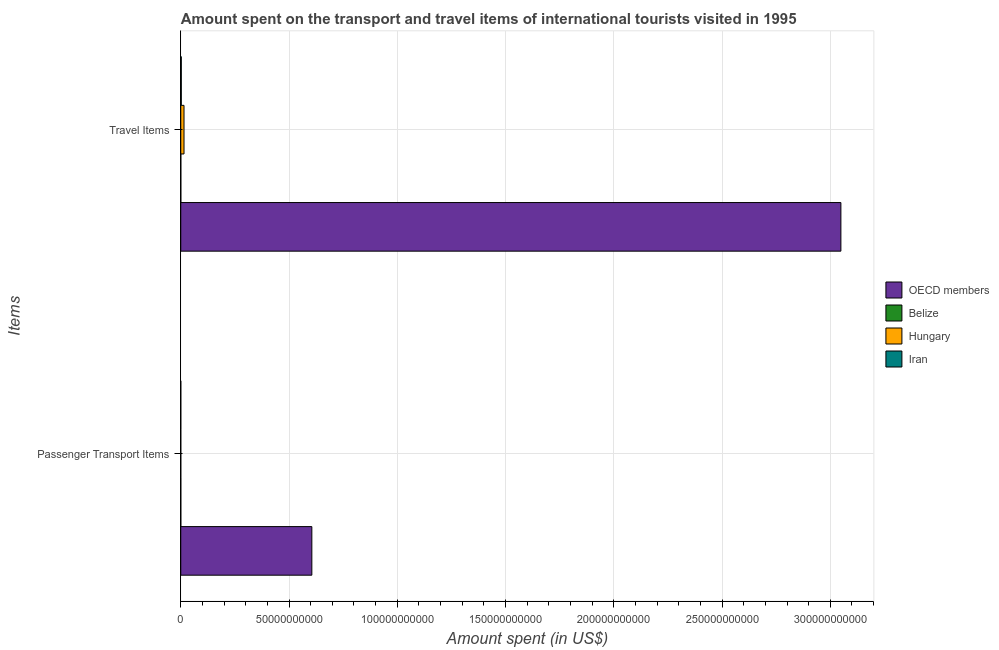How many different coloured bars are there?
Ensure brevity in your answer.  4. How many groups of bars are there?
Your answer should be very brief. 2. What is the label of the 2nd group of bars from the top?
Your response must be concise. Passenger Transport Items. Across all countries, what is the maximum amount spent in travel items?
Keep it short and to the point. 3.05e+11. Across all countries, what is the minimum amount spent on passenger transport items?
Provide a short and direct response. 3.00e+06. In which country was the amount spent in travel items minimum?
Give a very brief answer. Belize. What is the total amount spent in travel items in the graph?
Your answer should be compact. 3.07e+11. What is the difference between the amount spent in travel items in Belize and the amount spent on passenger transport items in OECD members?
Your response must be concise. -6.05e+1. What is the average amount spent in travel items per country?
Your response must be concise. 7.67e+1. What is the difference between the amount spent on passenger transport items and amount spent in travel items in Hungary?
Provide a succinct answer. -1.50e+09. What is the ratio of the amount spent in travel items in Hungary to that in OECD members?
Your answer should be very brief. 0. Is the amount spent on passenger transport items in Iran less than that in OECD members?
Your answer should be compact. Yes. What does the 1st bar from the top in Travel Items represents?
Offer a terse response. Iran. What does the 2nd bar from the bottom in Passenger Transport Items represents?
Make the answer very short. Belize. How many bars are there?
Keep it short and to the point. 8. How many countries are there in the graph?
Your answer should be very brief. 4. What is the difference between two consecutive major ticks on the X-axis?
Your answer should be compact. 5.00e+1. Are the values on the major ticks of X-axis written in scientific E-notation?
Your answer should be very brief. No. Does the graph contain any zero values?
Offer a very short reply. No. Does the graph contain grids?
Your answer should be compact. Yes. Where does the legend appear in the graph?
Give a very brief answer. Center right. What is the title of the graph?
Ensure brevity in your answer.  Amount spent on the transport and travel items of international tourists visited in 1995. Does "Zambia" appear as one of the legend labels in the graph?
Your response must be concise. No. What is the label or title of the X-axis?
Your answer should be very brief. Amount spent (in US$). What is the label or title of the Y-axis?
Ensure brevity in your answer.  Items. What is the Amount spent (in US$) in OECD members in Passenger Transport Items?
Provide a short and direct response. 6.05e+1. What is the Amount spent (in US$) of Belize in Passenger Transport Items?
Offer a very short reply. 1.20e+07. What is the Amount spent (in US$) in Hungary in Passenger Transport Items?
Your response must be concise. 3.00e+06. What is the Amount spent (in US$) in Iran in Passenger Transport Items?
Ensure brevity in your answer.  6.00e+06. What is the Amount spent (in US$) in OECD members in Travel Items?
Keep it short and to the point. 3.05e+11. What is the Amount spent (in US$) of Belize in Travel Items?
Your answer should be compact. 2.10e+07. What is the Amount spent (in US$) in Hungary in Travel Items?
Keep it short and to the point. 1.50e+09. What is the Amount spent (in US$) in Iran in Travel Items?
Provide a short and direct response. 2.41e+08. Across all Items, what is the maximum Amount spent (in US$) in OECD members?
Make the answer very short. 3.05e+11. Across all Items, what is the maximum Amount spent (in US$) of Belize?
Give a very brief answer. 2.10e+07. Across all Items, what is the maximum Amount spent (in US$) in Hungary?
Keep it short and to the point. 1.50e+09. Across all Items, what is the maximum Amount spent (in US$) of Iran?
Keep it short and to the point. 2.41e+08. Across all Items, what is the minimum Amount spent (in US$) in OECD members?
Your response must be concise. 6.05e+1. Across all Items, what is the minimum Amount spent (in US$) of Belize?
Give a very brief answer. 1.20e+07. Across all Items, what is the minimum Amount spent (in US$) in Hungary?
Offer a very short reply. 3.00e+06. Across all Items, what is the minimum Amount spent (in US$) of Iran?
Offer a terse response. 6.00e+06. What is the total Amount spent (in US$) of OECD members in the graph?
Your response must be concise. 3.65e+11. What is the total Amount spent (in US$) in Belize in the graph?
Provide a succinct answer. 3.30e+07. What is the total Amount spent (in US$) in Hungary in the graph?
Make the answer very short. 1.50e+09. What is the total Amount spent (in US$) of Iran in the graph?
Keep it short and to the point. 2.47e+08. What is the difference between the Amount spent (in US$) in OECD members in Passenger Transport Items and that in Travel Items?
Make the answer very short. -2.44e+11. What is the difference between the Amount spent (in US$) in Belize in Passenger Transport Items and that in Travel Items?
Ensure brevity in your answer.  -9.00e+06. What is the difference between the Amount spent (in US$) of Hungary in Passenger Transport Items and that in Travel Items?
Keep it short and to the point. -1.50e+09. What is the difference between the Amount spent (in US$) in Iran in Passenger Transport Items and that in Travel Items?
Provide a succinct answer. -2.35e+08. What is the difference between the Amount spent (in US$) in OECD members in Passenger Transport Items and the Amount spent (in US$) in Belize in Travel Items?
Your response must be concise. 6.05e+1. What is the difference between the Amount spent (in US$) in OECD members in Passenger Transport Items and the Amount spent (in US$) in Hungary in Travel Items?
Keep it short and to the point. 5.90e+1. What is the difference between the Amount spent (in US$) of OECD members in Passenger Transport Items and the Amount spent (in US$) of Iran in Travel Items?
Your answer should be compact. 6.03e+1. What is the difference between the Amount spent (in US$) of Belize in Passenger Transport Items and the Amount spent (in US$) of Hungary in Travel Items?
Your answer should be very brief. -1.49e+09. What is the difference between the Amount spent (in US$) of Belize in Passenger Transport Items and the Amount spent (in US$) of Iran in Travel Items?
Your response must be concise. -2.29e+08. What is the difference between the Amount spent (in US$) of Hungary in Passenger Transport Items and the Amount spent (in US$) of Iran in Travel Items?
Ensure brevity in your answer.  -2.38e+08. What is the average Amount spent (in US$) in OECD members per Items?
Give a very brief answer. 1.83e+11. What is the average Amount spent (in US$) of Belize per Items?
Provide a succinct answer. 1.65e+07. What is the average Amount spent (in US$) of Hungary per Items?
Keep it short and to the point. 7.50e+08. What is the average Amount spent (in US$) of Iran per Items?
Your answer should be very brief. 1.24e+08. What is the difference between the Amount spent (in US$) of OECD members and Amount spent (in US$) of Belize in Passenger Transport Items?
Your response must be concise. 6.05e+1. What is the difference between the Amount spent (in US$) of OECD members and Amount spent (in US$) of Hungary in Passenger Transport Items?
Your answer should be compact. 6.05e+1. What is the difference between the Amount spent (in US$) of OECD members and Amount spent (in US$) of Iran in Passenger Transport Items?
Your answer should be compact. 6.05e+1. What is the difference between the Amount spent (in US$) in Belize and Amount spent (in US$) in Hungary in Passenger Transport Items?
Ensure brevity in your answer.  9.00e+06. What is the difference between the Amount spent (in US$) of Belize and Amount spent (in US$) of Iran in Passenger Transport Items?
Provide a succinct answer. 6.00e+06. What is the difference between the Amount spent (in US$) of Hungary and Amount spent (in US$) of Iran in Passenger Transport Items?
Provide a succinct answer. -3.00e+06. What is the difference between the Amount spent (in US$) in OECD members and Amount spent (in US$) in Belize in Travel Items?
Offer a terse response. 3.05e+11. What is the difference between the Amount spent (in US$) of OECD members and Amount spent (in US$) of Hungary in Travel Items?
Give a very brief answer. 3.03e+11. What is the difference between the Amount spent (in US$) in OECD members and Amount spent (in US$) in Iran in Travel Items?
Offer a terse response. 3.05e+11. What is the difference between the Amount spent (in US$) in Belize and Amount spent (in US$) in Hungary in Travel Items?
Provide a short and direct response. -1.48e+09. What is the difference between the Amount spent (in US$) of Belize and Amount spent (in US$) of Iran in Travel Items?
Give a very brief answer. -2.20e+08. What is the difference between the Amount spent (in US$) of Hungary and Amount spent (in US$) of Iran in Travel Items?
Your answer should be very brief. 1.26e+09. What is the ratio of the Amount spent (in US$) in OECD members in Passenger Transport Items to that in Travel Items?
Make the answer very short. 0.2. What is the ratio of the Amount spent (in US$) in Hungary in Passenger Transport Items to that in Travel Items?
Your answer should be compact. 0. What is the ratio of the Amount spent (in US$) of Iran in Passenger Transport Items to that in Travel Items?
Provide a short and direct response. 0.02. What is the difference between the highest and the second highest Amount spent (in US$) of OECD members?
Ensure brevity in your answer.  2.44e+11. What is the difference between the highest and the second highest Amount spent (in US$) in Belize?
Your answer should be very brief. 9.00e+06. What is the difference between the highest and the second highest Amount spent (in US$) of Hungary?
Your answer should be compact. 1.50e+09. What is the difference between the highest and the second highest Amount spent (in US$) in Iran?
Give a very brief answer. 2.35e+08. What is the difference between the highest and the lowest Amount spent (in US$) of OECD members?
Your answer should be compact. 2.44e+11. What is the difference between the highest and the lowest Amount spent (in US$) in Belize?
Give a very brief answer. 9.00e+06. What is the difference between the highest and the lowest Amount spent (in US$) of Hungary?
Give a very brief answer. 1.50e+09. What is the difference between the highest and the lowest Amount spent (in US$) in Iran?
Keep it short and to the point. 2.35e+08. 